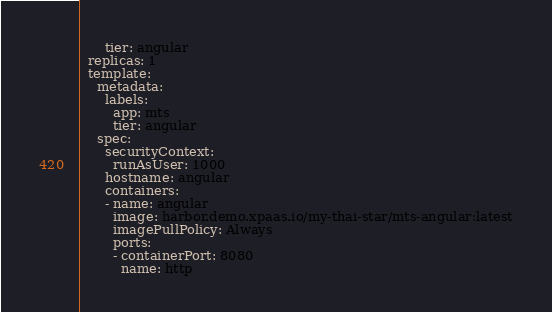<code> <loc_0><loc_0><loc_500><loc_500><_YAML_>      tier: angular
  replicas: 1
  template:
    metadata:
      labels:
        app: mts
        tier: angular
    spec:
      securityContext:
        runAsUser: 1000
      hostname: angular
      containers:
      - name: angular
        image: harbor.demo.xpaas.io/my-thai-star/mts-angular:latest
        imagePullPolicy: Always
        ports:
        - containerPort: 8080
          name: http</code> 